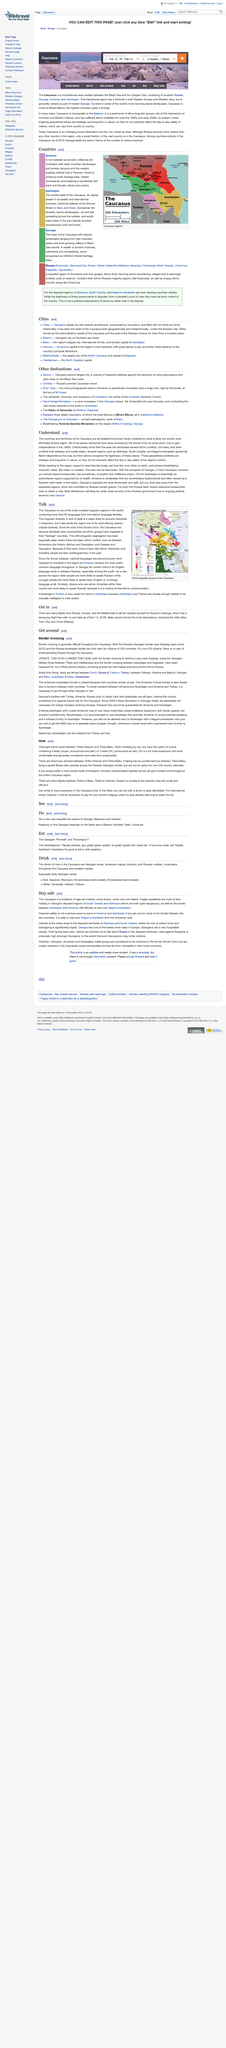List a handful of essential elements in this visual. Georgian wines are notable in the Caucasus region. If you love meat, you should try the Georgian dishes of "kabab" and "dushbara" under the heading of "The Georgian 'Khinkali' and 'Khachapuri'. The Caucasus offers excellent values in drinks, particularly in local beers. 